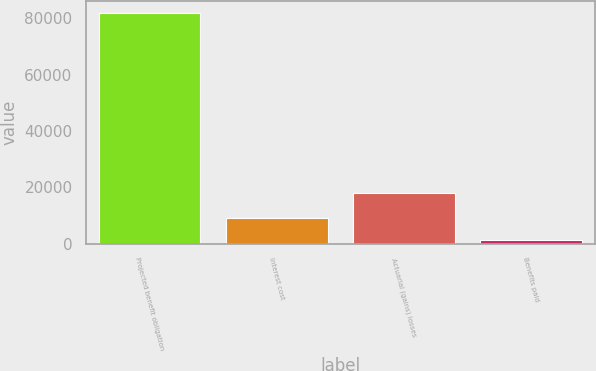Convert chart to OTSL. <chart><loc_0><loc_0><loc_500><loc_500><bar_chart><fcel>Projected benefit obligation<fcel>Interest cost<fcel>Actuarial (gains) losses<fcel>Benefits paid<nl><fcel>82006<fcel>9276.1<fcel>17967<fcel>1195<nl></chart> 